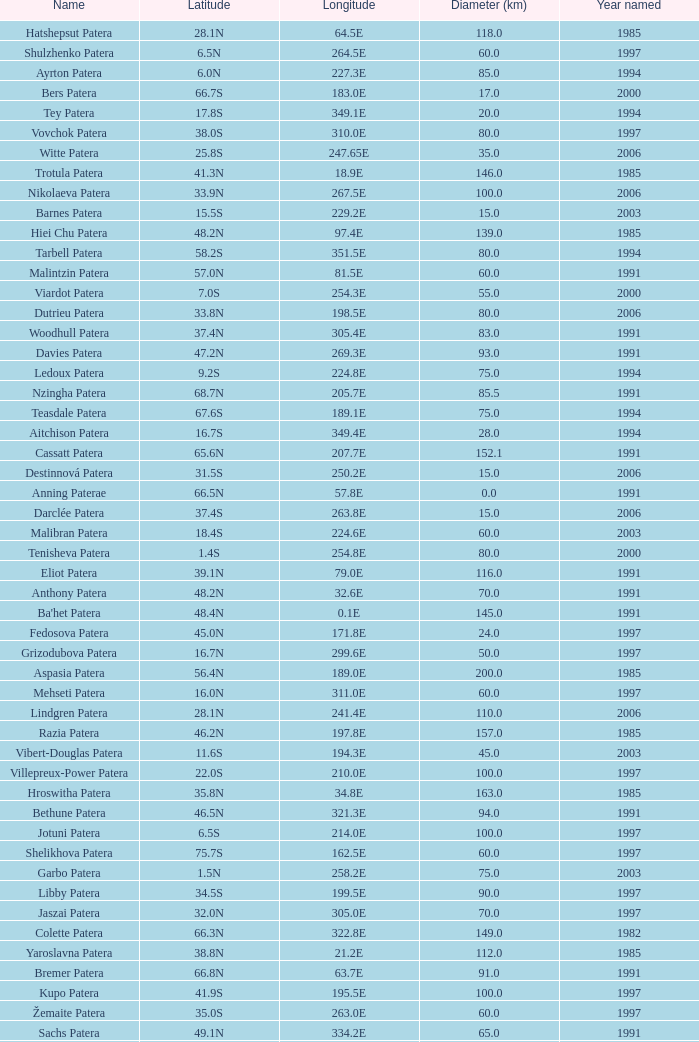What is the average Year Named, when Latitude is 37.9N, and when Diameter (km) is greater than 76? None. 